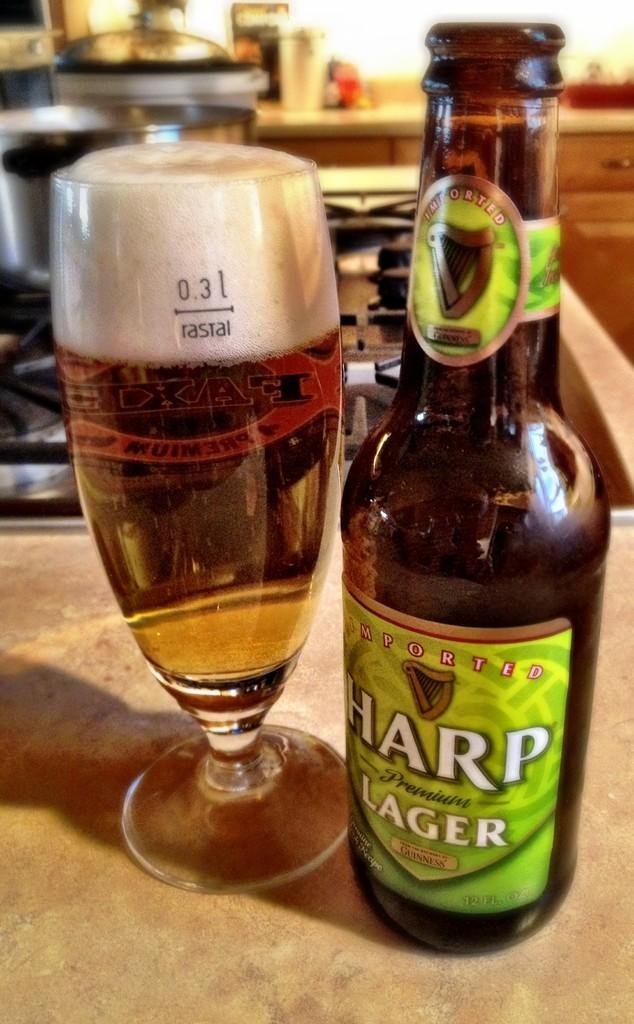Provide a one-sentence caption for the provided image. A bottle of Harp lager sits next to a full glass of beer. 